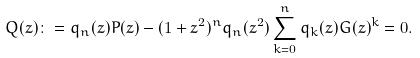<formula> <loc_0><loc_0><loc_500><loc_500>Q ( z ) \colon = q _ { n } ( z ) P ( z ) - ( 1 + z ^ { 2 } ) ^ { n } q _ { n } ( z ^ { 2 } ) \sum _ { k = 0 } ^ { n } q _ { k } ( z ) G ( z ) ^ { k } = 0 .</formula> 